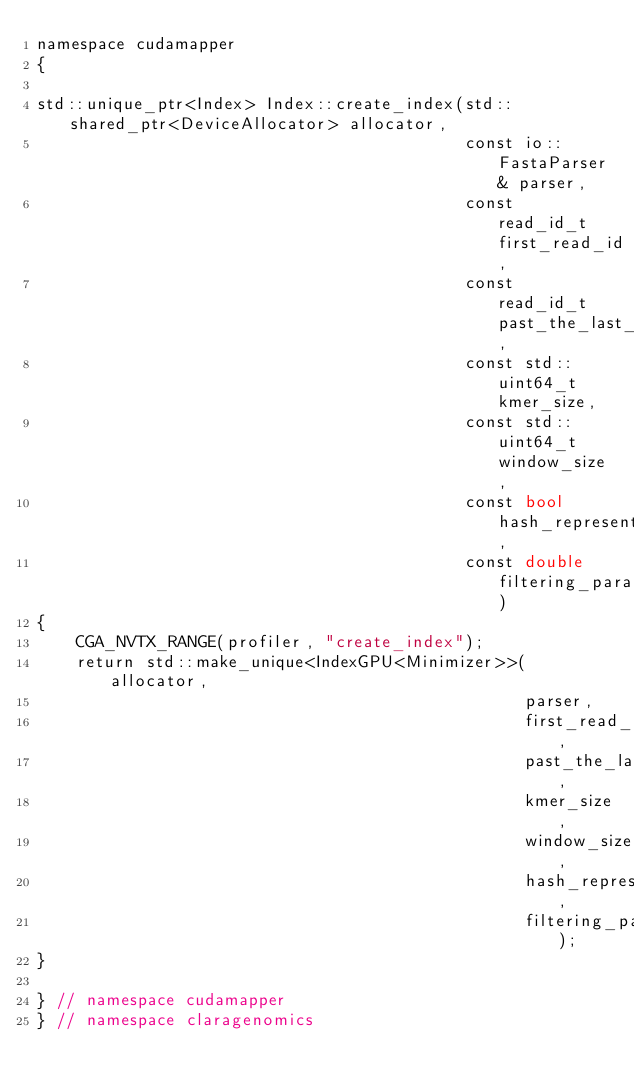<code> <loc_0><loc_0><loc_500><loc_500><_Cuda_>namespace cudamapper
{

std::unique_ptr<Index> Index::create_index(std::shared_ptr<DeviceAllocator> allocator,
                                           const io::FastaParser& parser,
                                           const read_id_t first_read_id,
                                           const read_id_t past_the_last_read_id,
                                           const std::uint64_t kmer_size,
                                           const std::uint64_t window_size,
                                           const bool hash_representations,
                                           const double filtering_parameter)
{
    CGA_NVTX_RANGE(profiler, "create_index");
    return std::make_unique<IndexGPU<Minimizer>>(allocator,
                                                 parser,
                                                 first_read_id,
                                                 past_the_last_read_id,
                                                 kmer_size,
                                                 window_size,
                                                 hash_representations,
                                                 filtering_parameter);
}

} // namespace cudamapper
} // namespace claragenomics
</code> 